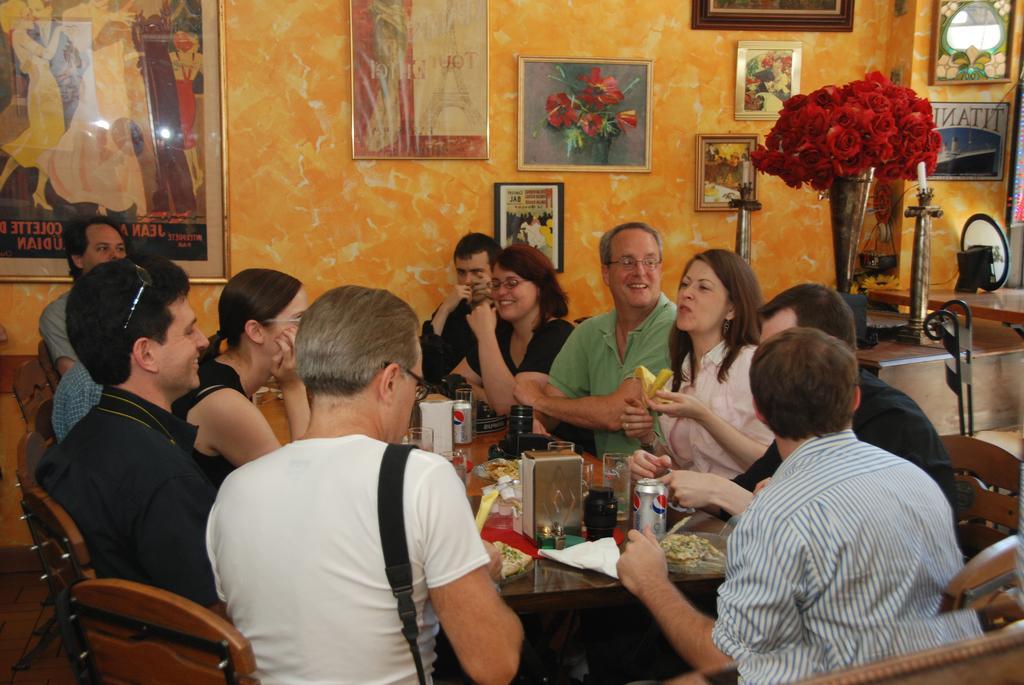Could you give a brief overview of what you see in this image? there are so many people sitting around a dining table behind them there is a red flowers ways and photo frames on the wall. 